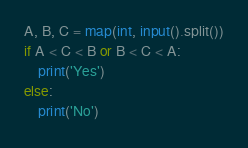Convert code to text. <code><loc_0><loc_0><loc_500><loc_500><_Python_>A, B, C = map(int, input().split())
if A < C < B or B < C < A:
    print('Yes')
else:
    print('No')</code> 